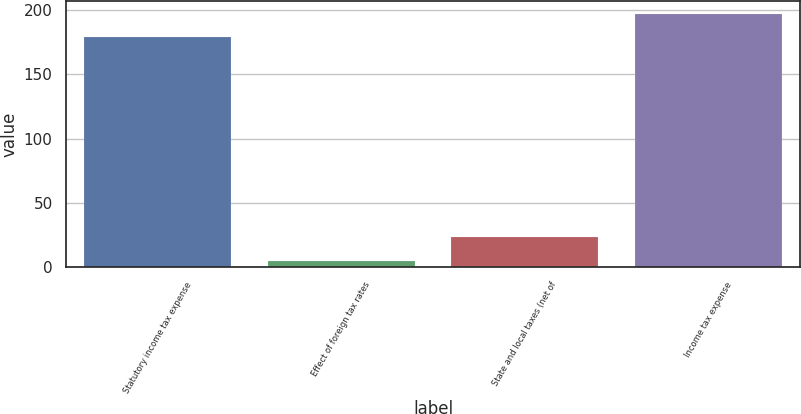<chart> <loc_0><loc_0><loc_500><loc_500><bar_chart><fcel>Statutory income tax expense<fcel>Effect of foreign tax rates<fcel>State and local taxes (net of<fcel>Income tax expense<nl><fcel>179<fcel>5<fcel>23.4<fcel>197.4<nl></chart> 